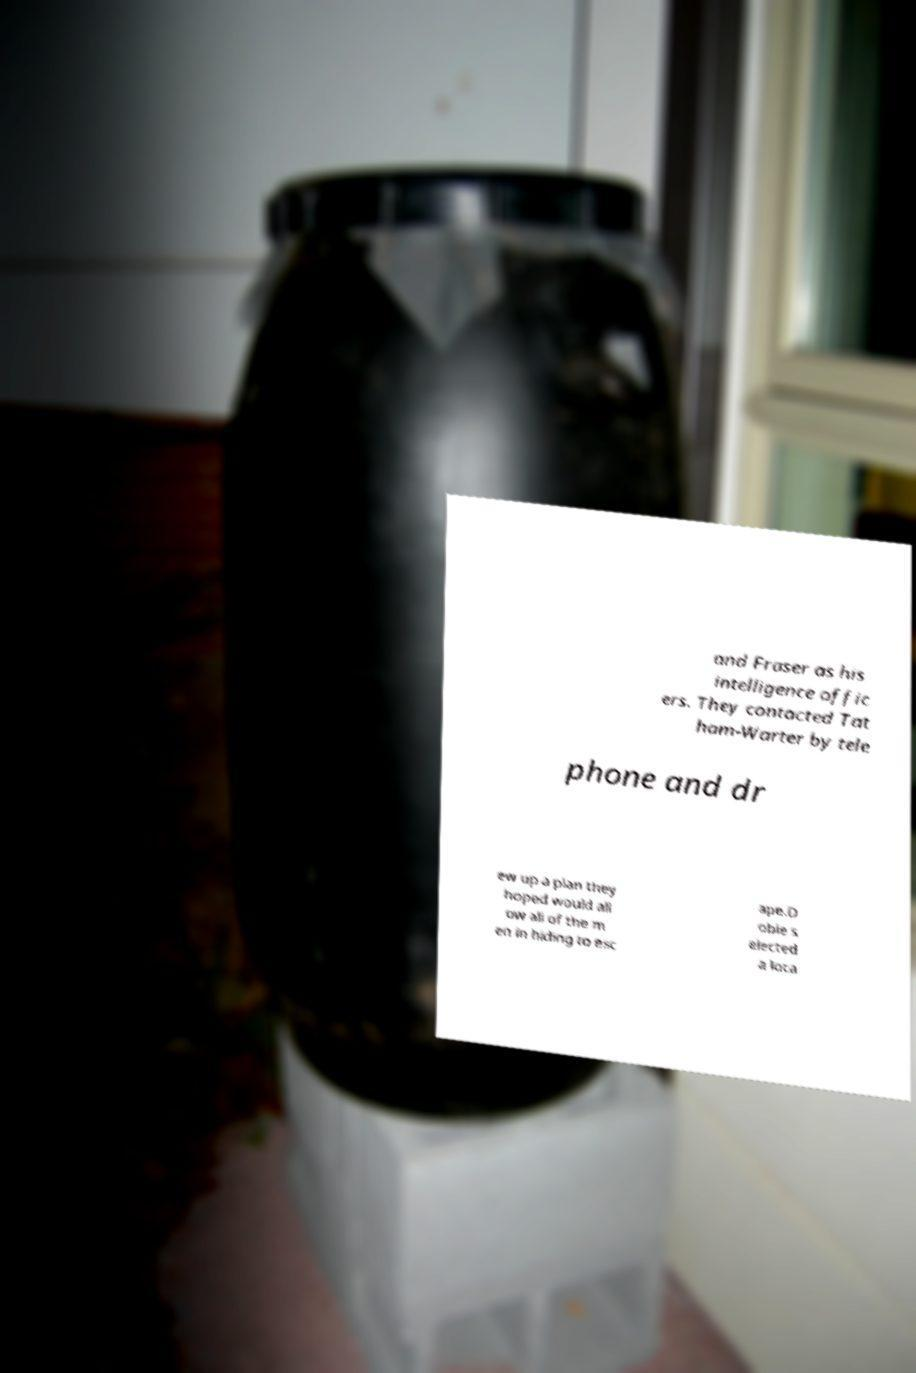Can you accurately transcribe the text from the provided image for me? and Fraser as his intelligence offic ers. They contacted Tat ham-Warter by tele phone and dr ew up a plan they hoped would all ow all of the m en in hiding to esc ape.D obie s elected a loca 